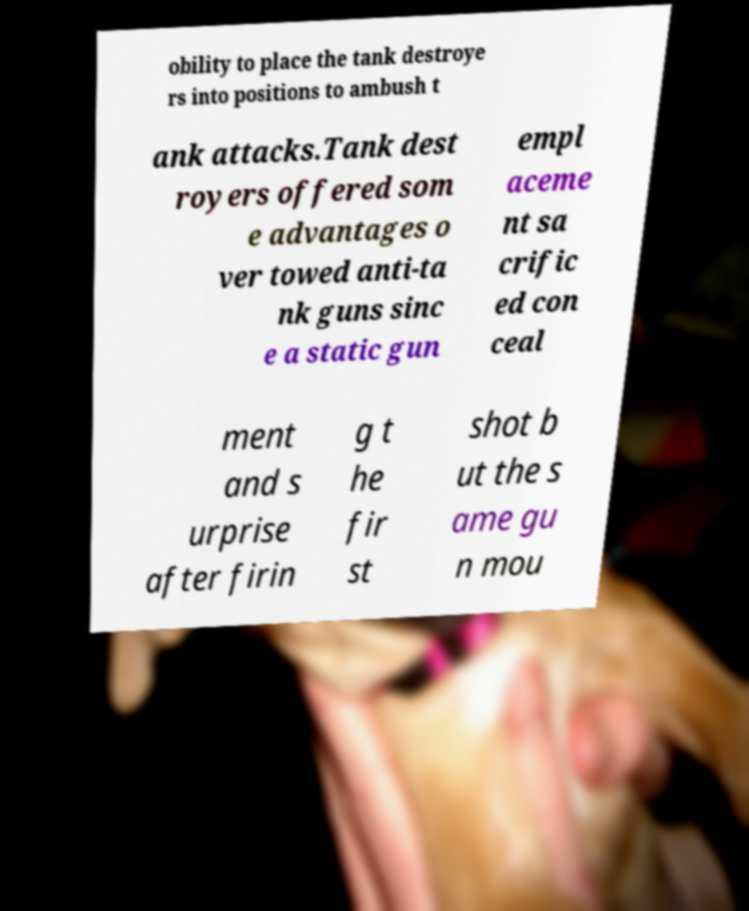What messages or text are displayed in this image? I need them in a readable, typed format. obility to place the tank destroye rs into positions to ambush t ank attacks.Tank dest royers offered som e advantages o ver towed anti-ta nk guns sinc e a static gun empl aceme nt sa crific ed con ceal ment and s urprise after firin g t he fir st shot b ut the s ame gu n mou 